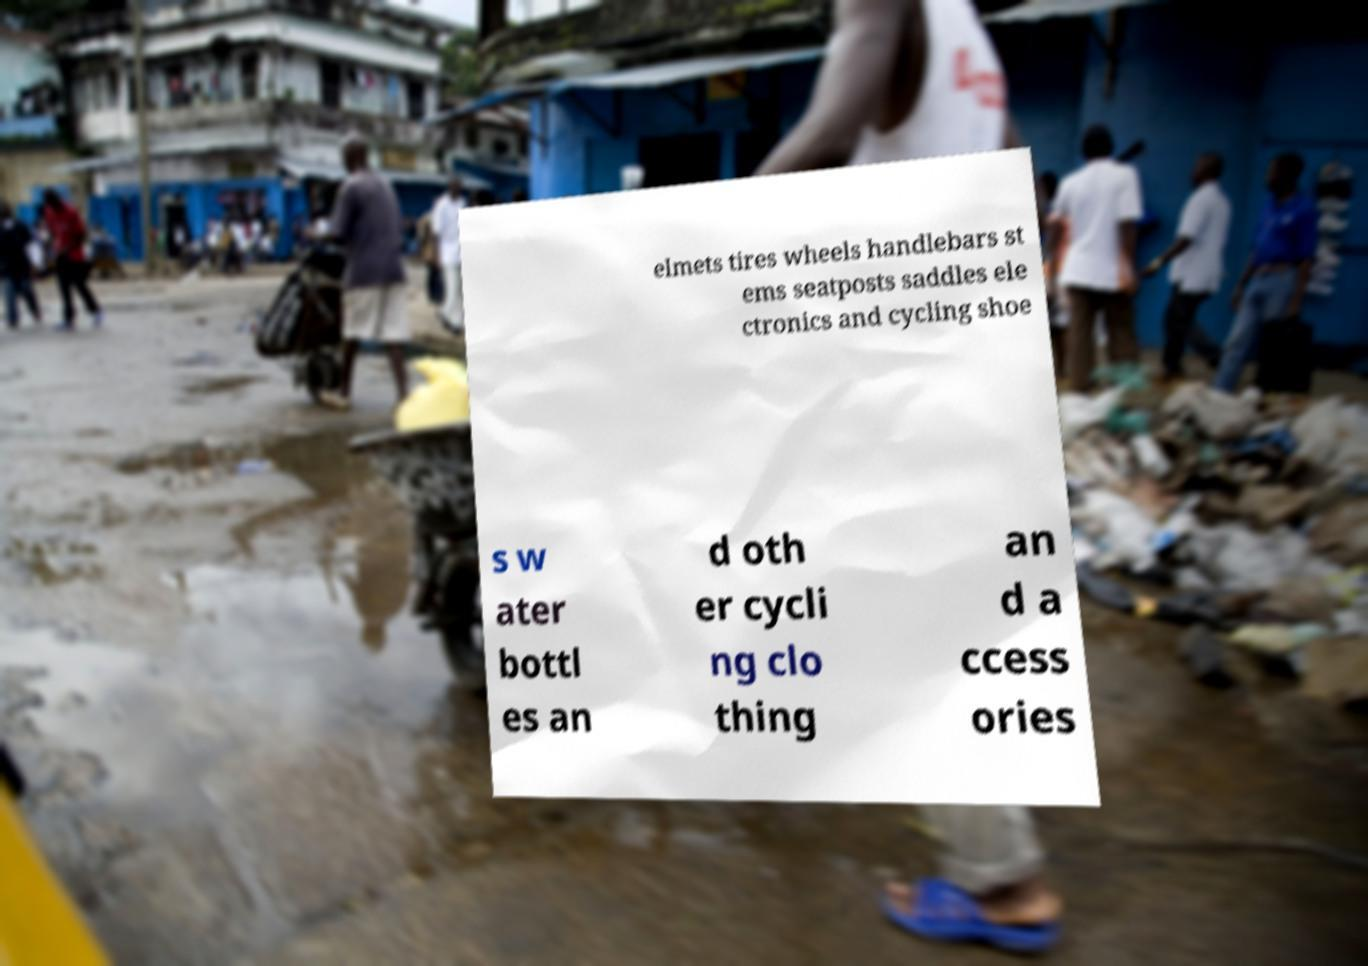Please identify and transcribe the text found in this image. elmets tires wheels handlebars st ems seatposts saddles ele ctronics and cycling shoe s w ater bottl es an d oth er cycli ng clo thing an d a ccess ories 